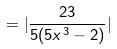<formula> <loc_0><loc_0><loc_500><loc_500>= | \frac { 2 3 } { 5 ( 5 x ^ { 3 } - 2 ) } |</formula> 